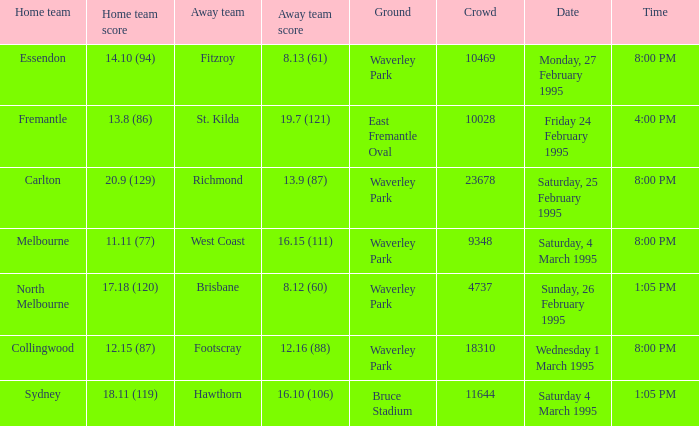Name the total number of grounds for essendon 1.0. 